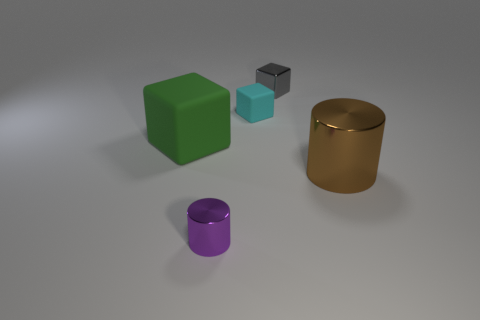What time of day does this lighting suggest, and what kind of mood does it evoke? The lighting in the image is soft and diffuse, consistent with early morning or late afternoon natural light. It creates a calm, contemplative mood, with gentle shadows that enhance the shapes of the objects without creating harsh contrasts. 